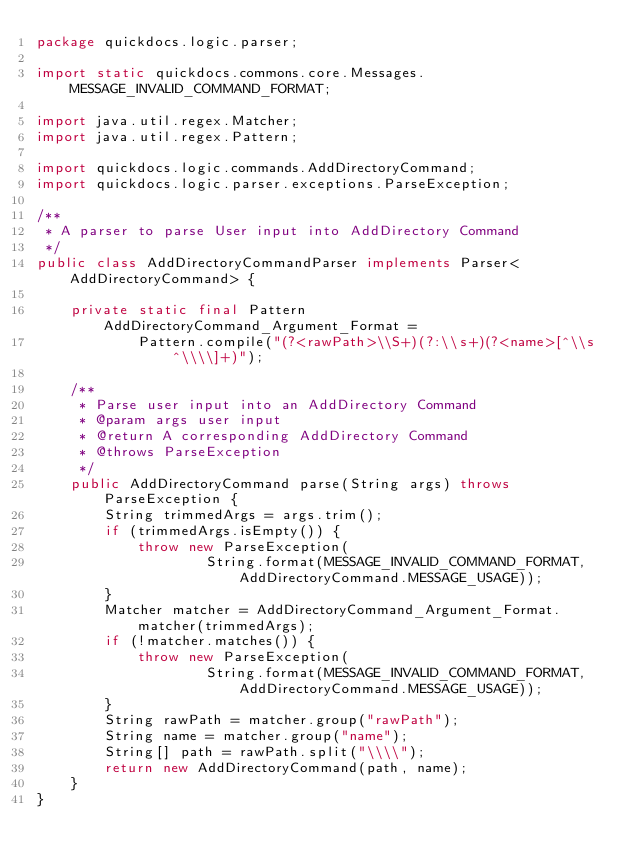Convert code to text. <code><loc_0><loc_0><loc_500><loc_500><_Java_>package quickdocs.logic.parser;

import static quickdocs.commons.core.Messages.MESSAGE_INVALID_COMMAND_FORMAT;

import java.util.regex.Matcher;
import java.util.regex.Pattern;

import quickdocs.logic.commands.AddDirectoryCommand;
import quickdocs.logic.parser.exceptions.ParseException;

/**
 * A parser to parse User input into AddDirectory Command
 */
public class AddDirectoryCommandParser implements Parser<AddDirectoryCommand> {

    private static final Pattern AddDirectoryCommand_Argument_Format =
            Pattern.compile("(?<rawPath>\\S+)(?:\\s+)(?<name>[^\\s^\\\\]+)");

    /**
     * Parse user input into an AddDirectory Command
     * @param args user input
     * @return A corresponding AddDirectory Command
     * @throws ParseException
     */
    public AddDirectoryCommand parse(String args) throws ParseException {
        String trimmedArgs = args.trim();
        if (trimmedArgs.isEmpty()) {
            throw new ParseException(
                    String.format(MESSAGE_INVALID_COMMAND_FORMAT, AddDirectoryCommand.MESSAGE_USAGE));
        }
        Matcher matcher = AddDirectoryCommand_Argument_Format.matcher(trimmedArgs);
        if (!matcher.matches()) {
            throw new ParseException(
                    String.format(MESSAGE_INVALID_COMMAND_FORMAT, AddDirectoryCommand.MESSAGE_USAGE));
        }
        String rawPath = matcher.group("rawPath");
        String name = matcher.group("name");
        String[] path = rawPath.split("\\\\");
        return new AddDirectoryCommand(path, name);
    }
}
</code> 